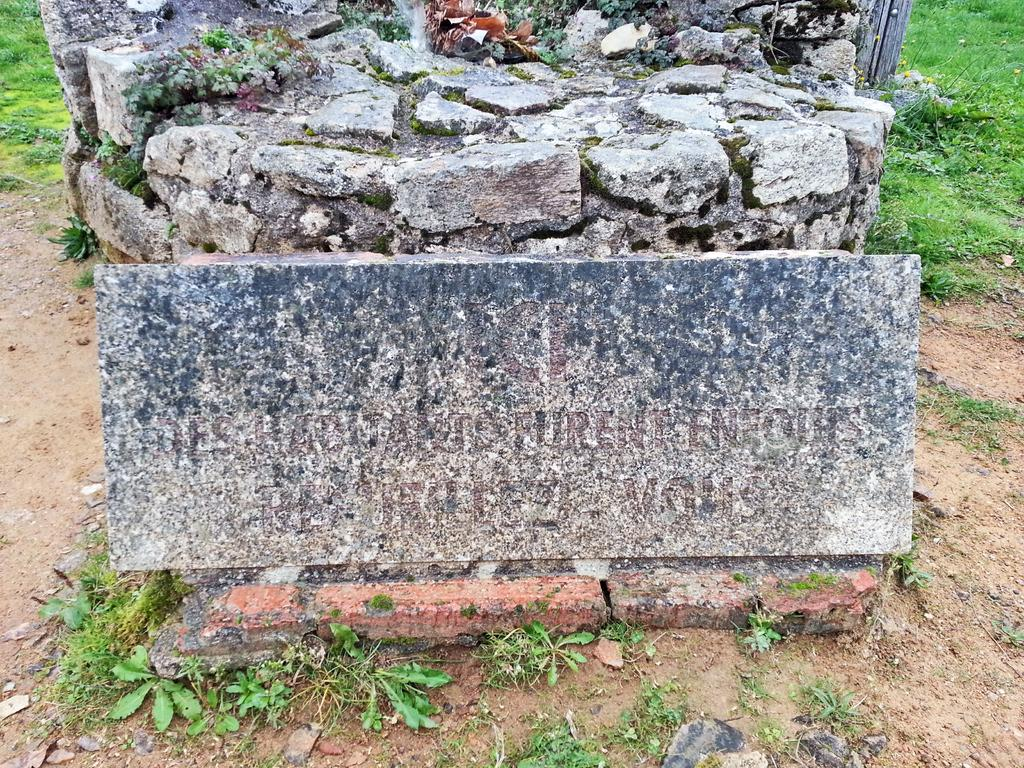What is the main object in the image? There is a marble with text in the image. What can be seen in the background of the image? There are plants and grass in the background of the image. What type of structure is present in the image? There is a stone wall in the image. What type of cream is being advertised in the image? There is no advertisement or cream present in the image; it features a marble with text and a stone wall. What type of jewel can be seen on the marble in the image? There is no jewel present on the marble in the image; it only has text. 